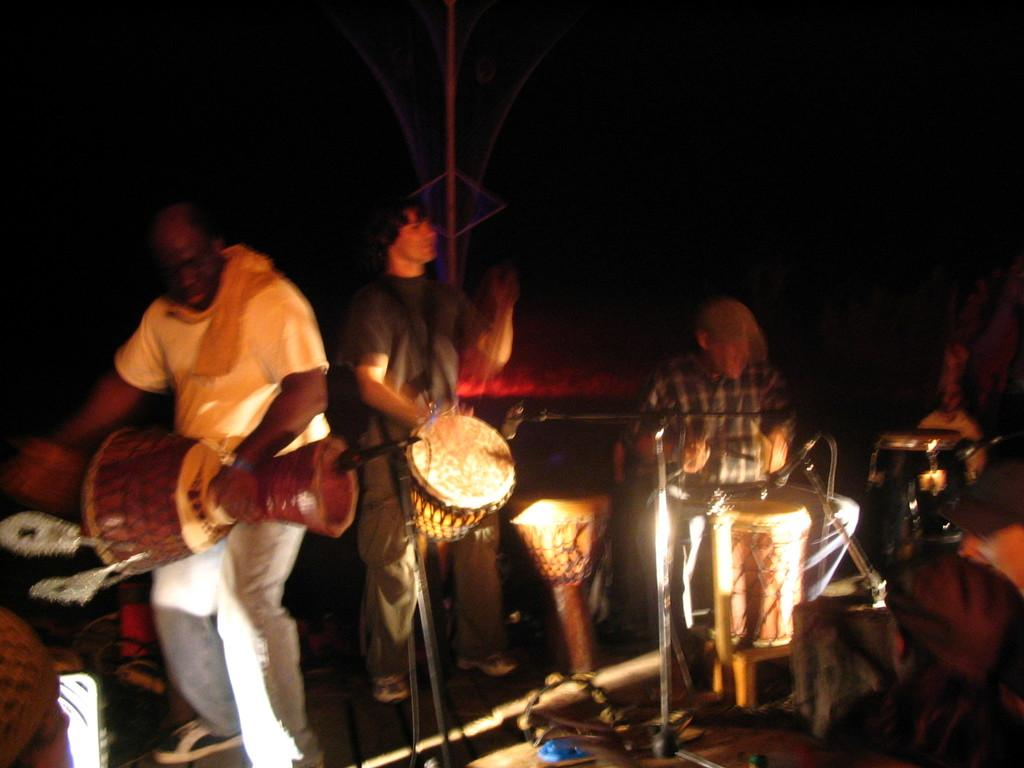What are the people in the image doing? The people in the image are playing musical instruments. Can you describe the man with the checked shirt in the image? The man with the checked shirt is playing a drum. How many men are standing in the image? There are two men standing in the image. What are the two standing men playing? The two standing men are playing drums. What type of ice can be seen melting on the floor in the image? There is no ice present in the image; it features people playing musical instruments. What club is the man with the checked shirt a member of in the image? There is no information about a club in the image; it only shows people playing musical instruments. 